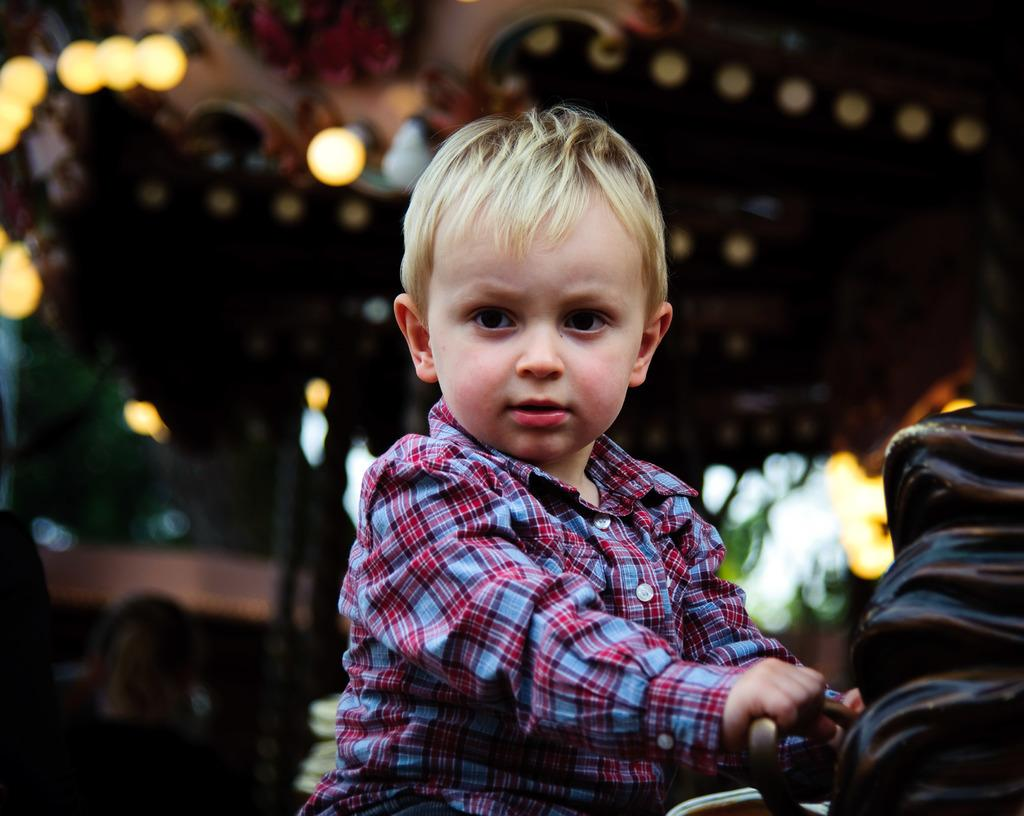Who is the main subject in the image? There is a boy in the image. What is the boy holding in the image? The boy is holding a bag. Can you describe the color of the bag? The bag is black in color. What can be observed about the background of the image? The background of the image is blurry. What else is visible in the background? There are lights visible in the background. How many ants are crawling on the boy's arm in the image? There are no ants visible on the boy's arm in the image. What month is it in the image? The month cannot be determined from the image, as there is no information about the time of year. 